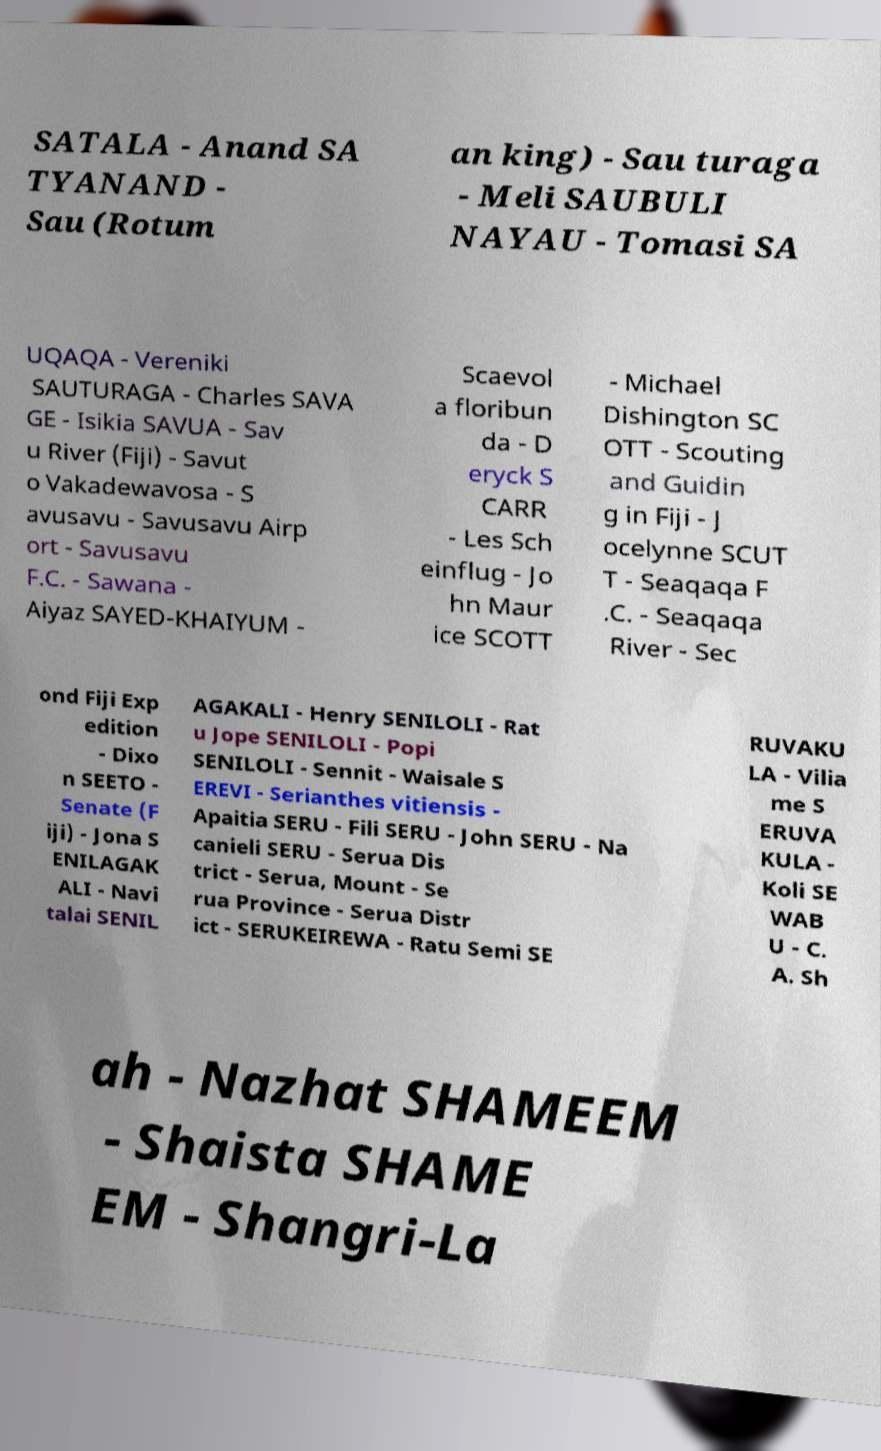There's text embedded in this image that I need extracted. Can you transcribe it verbatim? SATALA - Anand SA TYANAND - Sau (Rotum an king) - Sau turaga - Meli SAUBULI NAYAU - Tomasi SA UQAQA - Vereniki SAUTURAGA - Charles SAVA GE - Isikia SAVUA - Sav u River (Fiji) - Savut o Vakadewavosa - S avusavu - Savusavu Airp ort - Savusavu F.C. - Sawana - Aiyaz SAYED-KHAIYUM - Scaevol a floribun da - D eryck S CARR - Les Sch einflug - Jo hn Maur ice SCOTT - Michael Dishington SC OTT - Scouting and Guidin g in Fiji - J ocelynne SCUT T - Seaqaqa F .C. - Seaqaqa River - Sec ond Fiji Exp edition - Dixo n SEETO - Senate (F iji) - Jona S ENILAGAK ALI - Navi talai SENIL AGAKALI - Henry SENILOLI - Rat u Jope SENILOLI - Popi SENILOLI - Sennit - Waisale S EREVI - Serianthes vitiensis - Apaitia SERU - Fili SERU - John SERU - Na canieli SERU - Serua Dis trict - Serua, Mount - Se rua Province - Serua Distr ict - SERUKEIREWA - Ratu Semi SE RUVAKU LA - Vilia me S ERUVA KULA - Koli SE WAB U - C. A. Sh ah - Nazhat SHAMEEM - Shaista SHAME EM - Shangri-La 